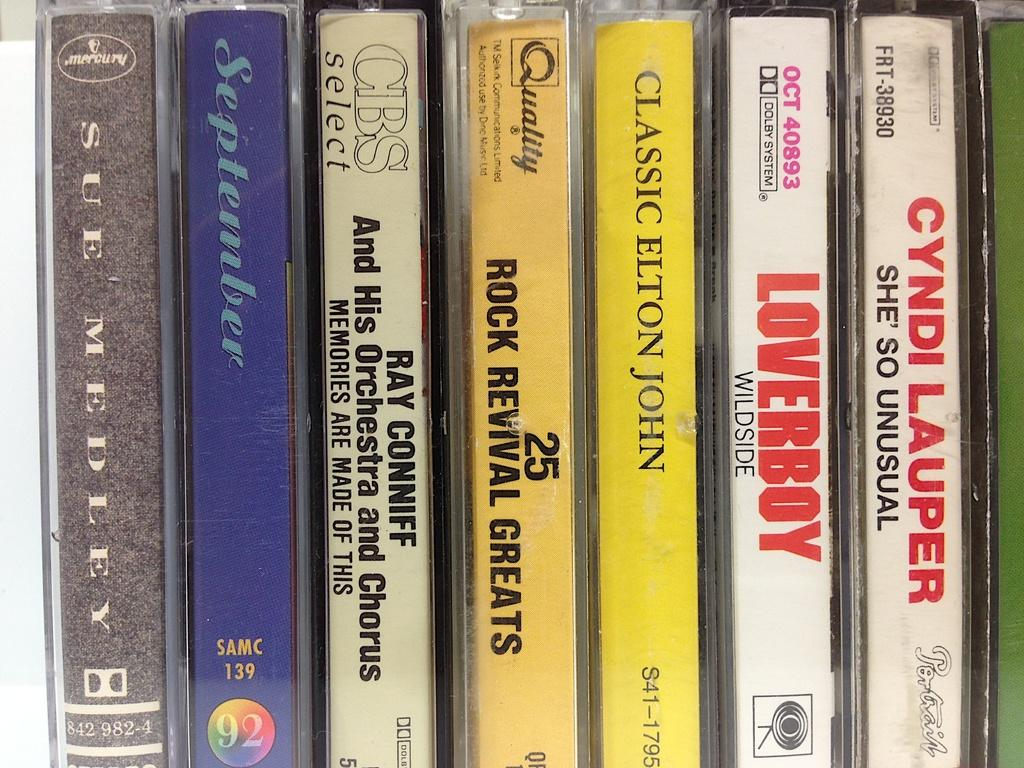<image>
Write a terse but informative summary of the picture. Seven cassette tapes including Loverboy all lined up. 